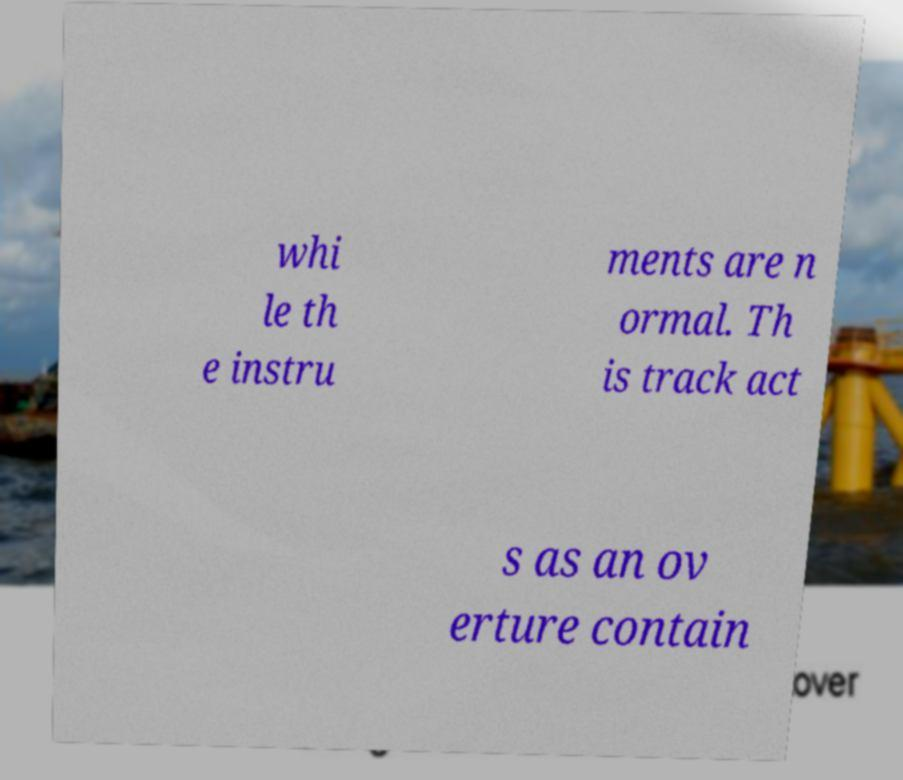I need the written content from this picture converted into text. Can you do that? whi le th e instru ments are n ormal. Th is track act s as an ov erture contain 